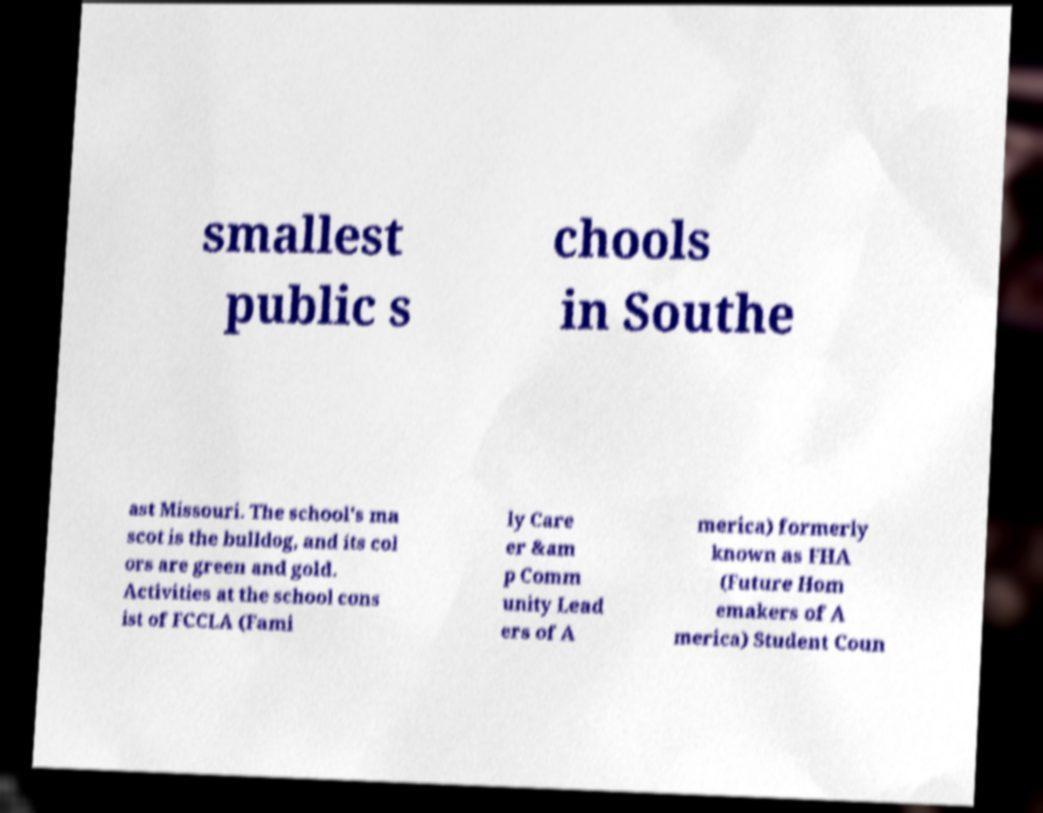Could you extract and type out the text from this image? smallest public s chools in Southe ast Missouri. The school's ma scot is the bulldog, and its col ors are green and gold. Activities at the school cons ist of FCCLA (Fami ly Care er &am p Comm unity Lead ers of A merica) formerly known as FHA (Future Hom emakers of A merica) Student Coun 